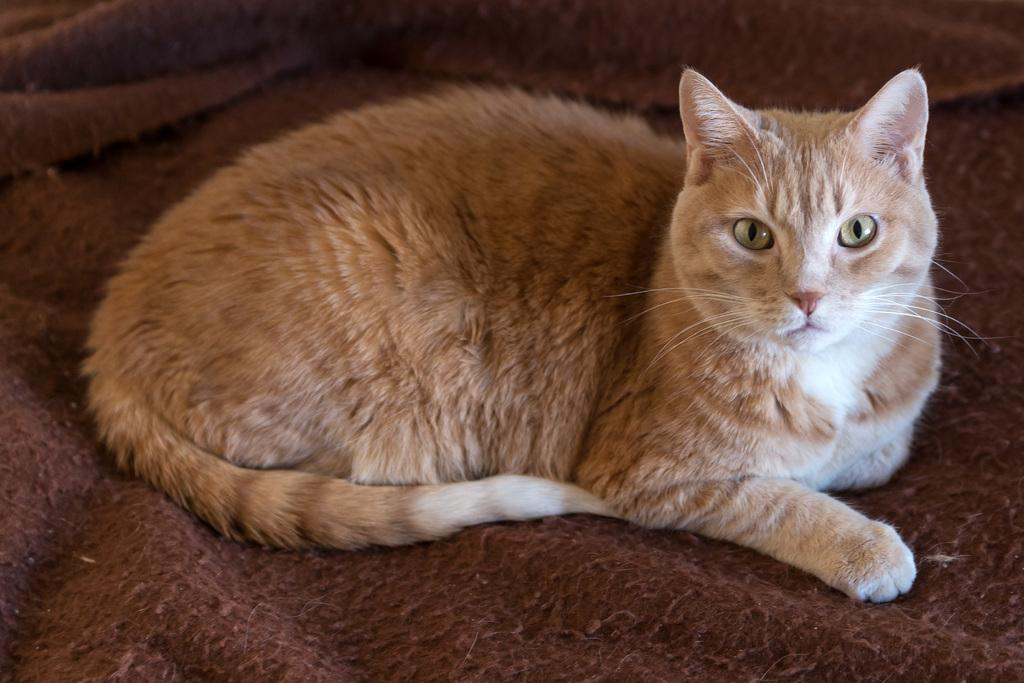What color is the cloth in the image? The cloth in the image is brown-colored. What is on top of the cloth? There is a green and white-colored cat on the cloth. Where is the oven located in the image? There is no oven present in the image. Is the team playing a game on the cloth in the image? There is no team or game present in the image; it features a brown-colored cloth with a green and white-colored cat on it. 